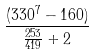Convert formula to latex. <formula><loc_0><loc_0><loc_500><loc_500>\frac { ( 3 3 0 ^ { 7 } - 1 6 0 ) } { \frac { 2 5 3 } { 4 1 9 } + 2 }</formula> 